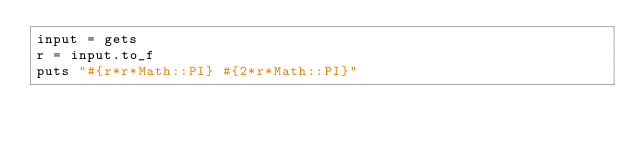<code> <loc_0><loc_0><loc_500><loc_500><_Ruby_>input = gets
r = input.to_f
puts "#{r*r*Math::PI} #{2*r*Math::PI}"</code> 